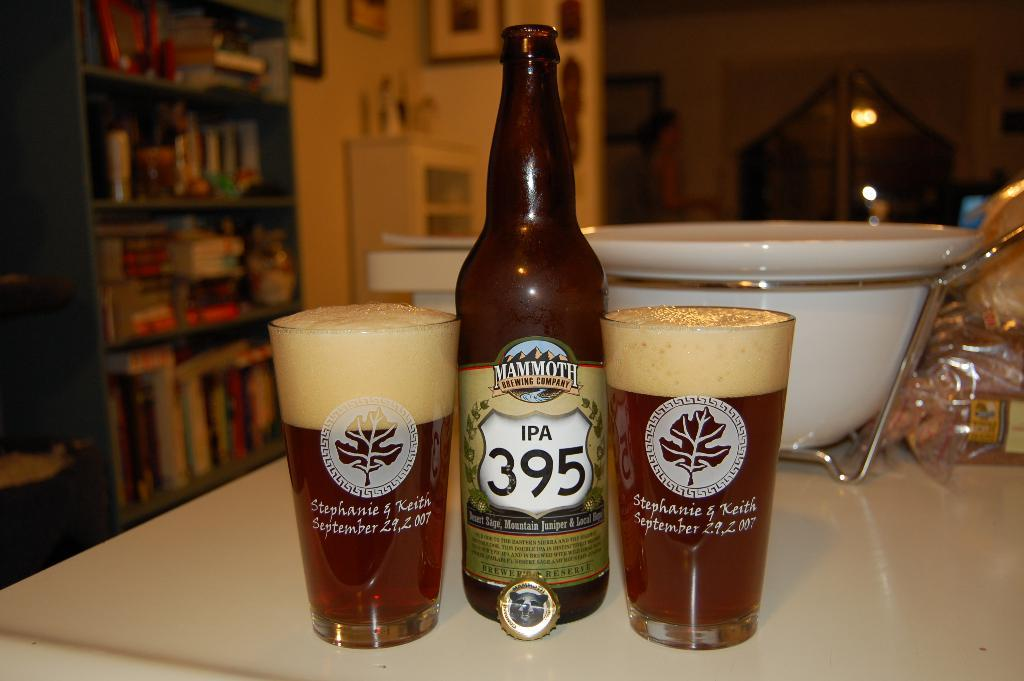<image>
Provide a brief description of the given image. A bottle of IPA 395 has been poured into two glasses 